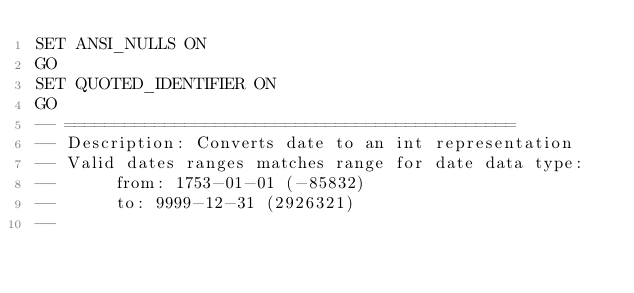Convert code to text. <code><loc_0><loc_0><loc_500><loc_500><_SQL_>SET ANSI_NULLS ON
GO
SET QUOTED_IDENTIFIER ON
GO
-- =============================================
-- Description:	Converts date to an int representation
-- Valid dates ranges matches range for date data type: 
--		from: 1753-01-01 (-85832) 
--		to: 9999-12-31 (2926321)
--</code> 